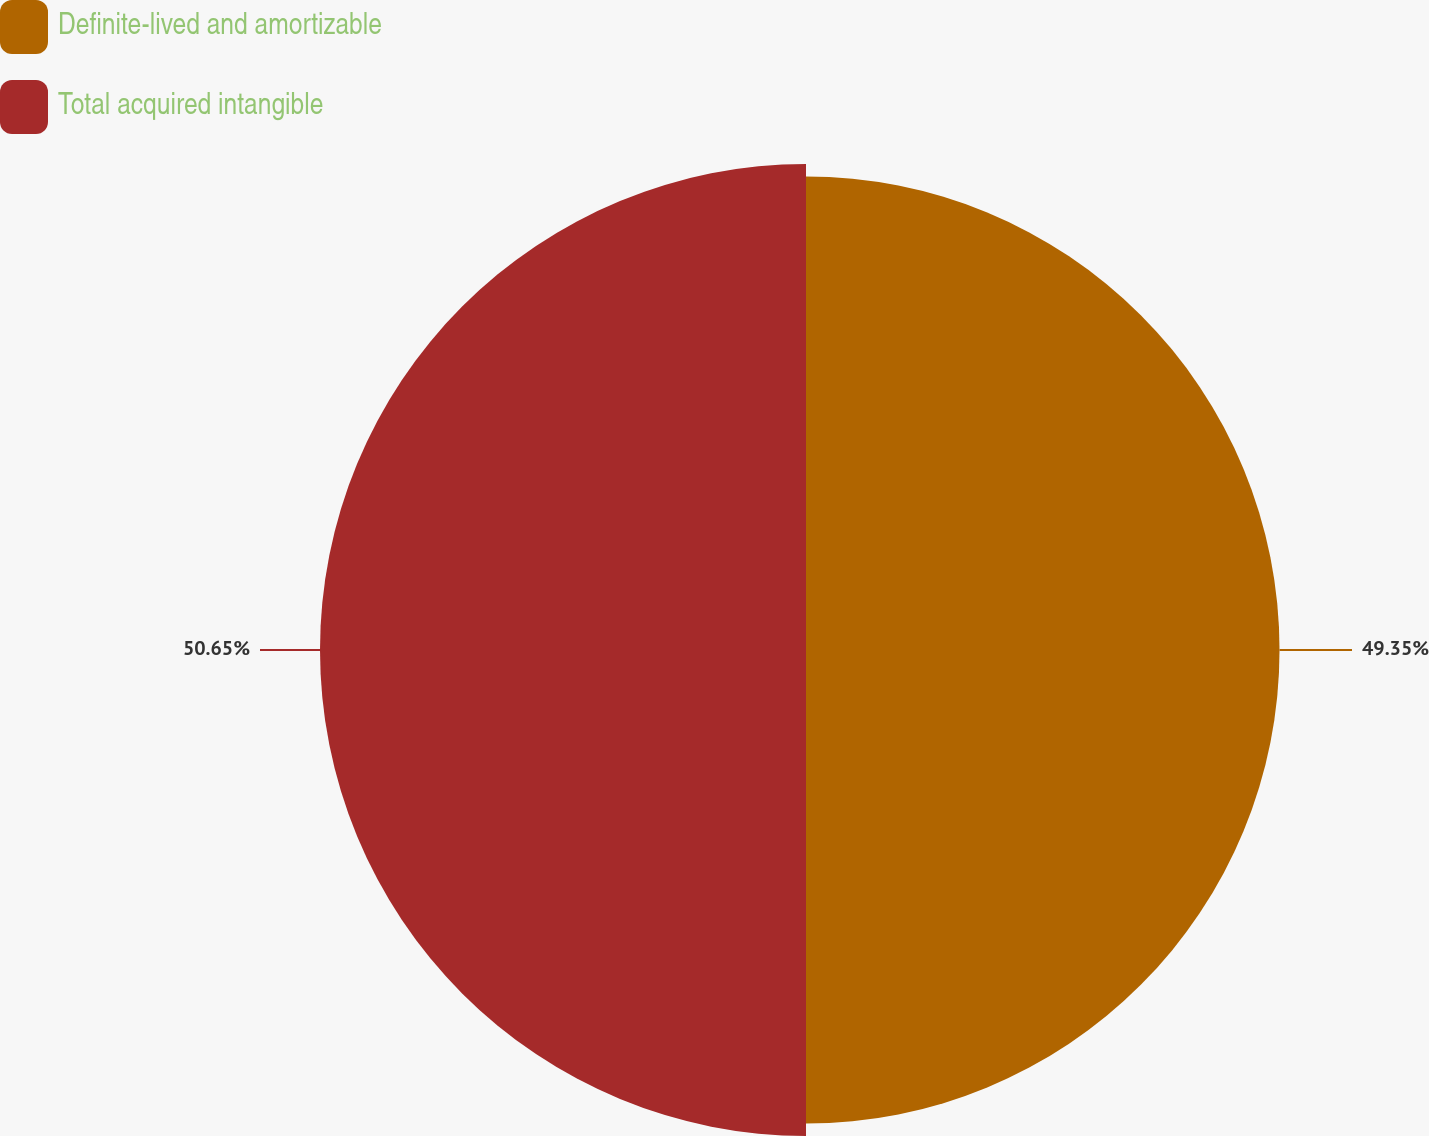Convert chart to OTSL. <chart><loc_0><loc_0><loc_500><loc_500><pie_chart><fcel>Definite-lived and amortizable<fcel>Total acquired intangible<nl><fcel>49.35%<fcel>50.65%<nl></chart> 